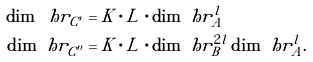<formula> <loc_0><loc_0><loc_500><loc_500>\dim \ h r _ { C ^ { \prime } } & = K \cdot L \cdot \dim \ h r _ { A } ^ { l } \\ \dim \ h r _ { C ^ { \prime \prime } } & = K \cdot L \cdot \dim \ h r _ { B } ^ { 2 l } \dim \ h r _ { A } ^ { l } .</formula> 